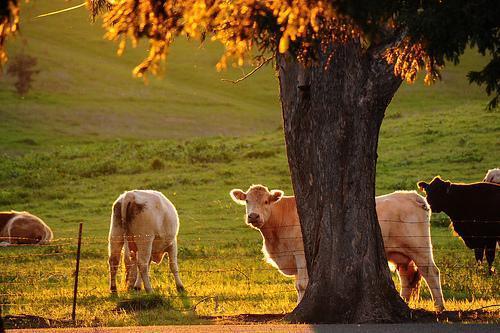How many cows are there?
Give a very brief answer. 5. 